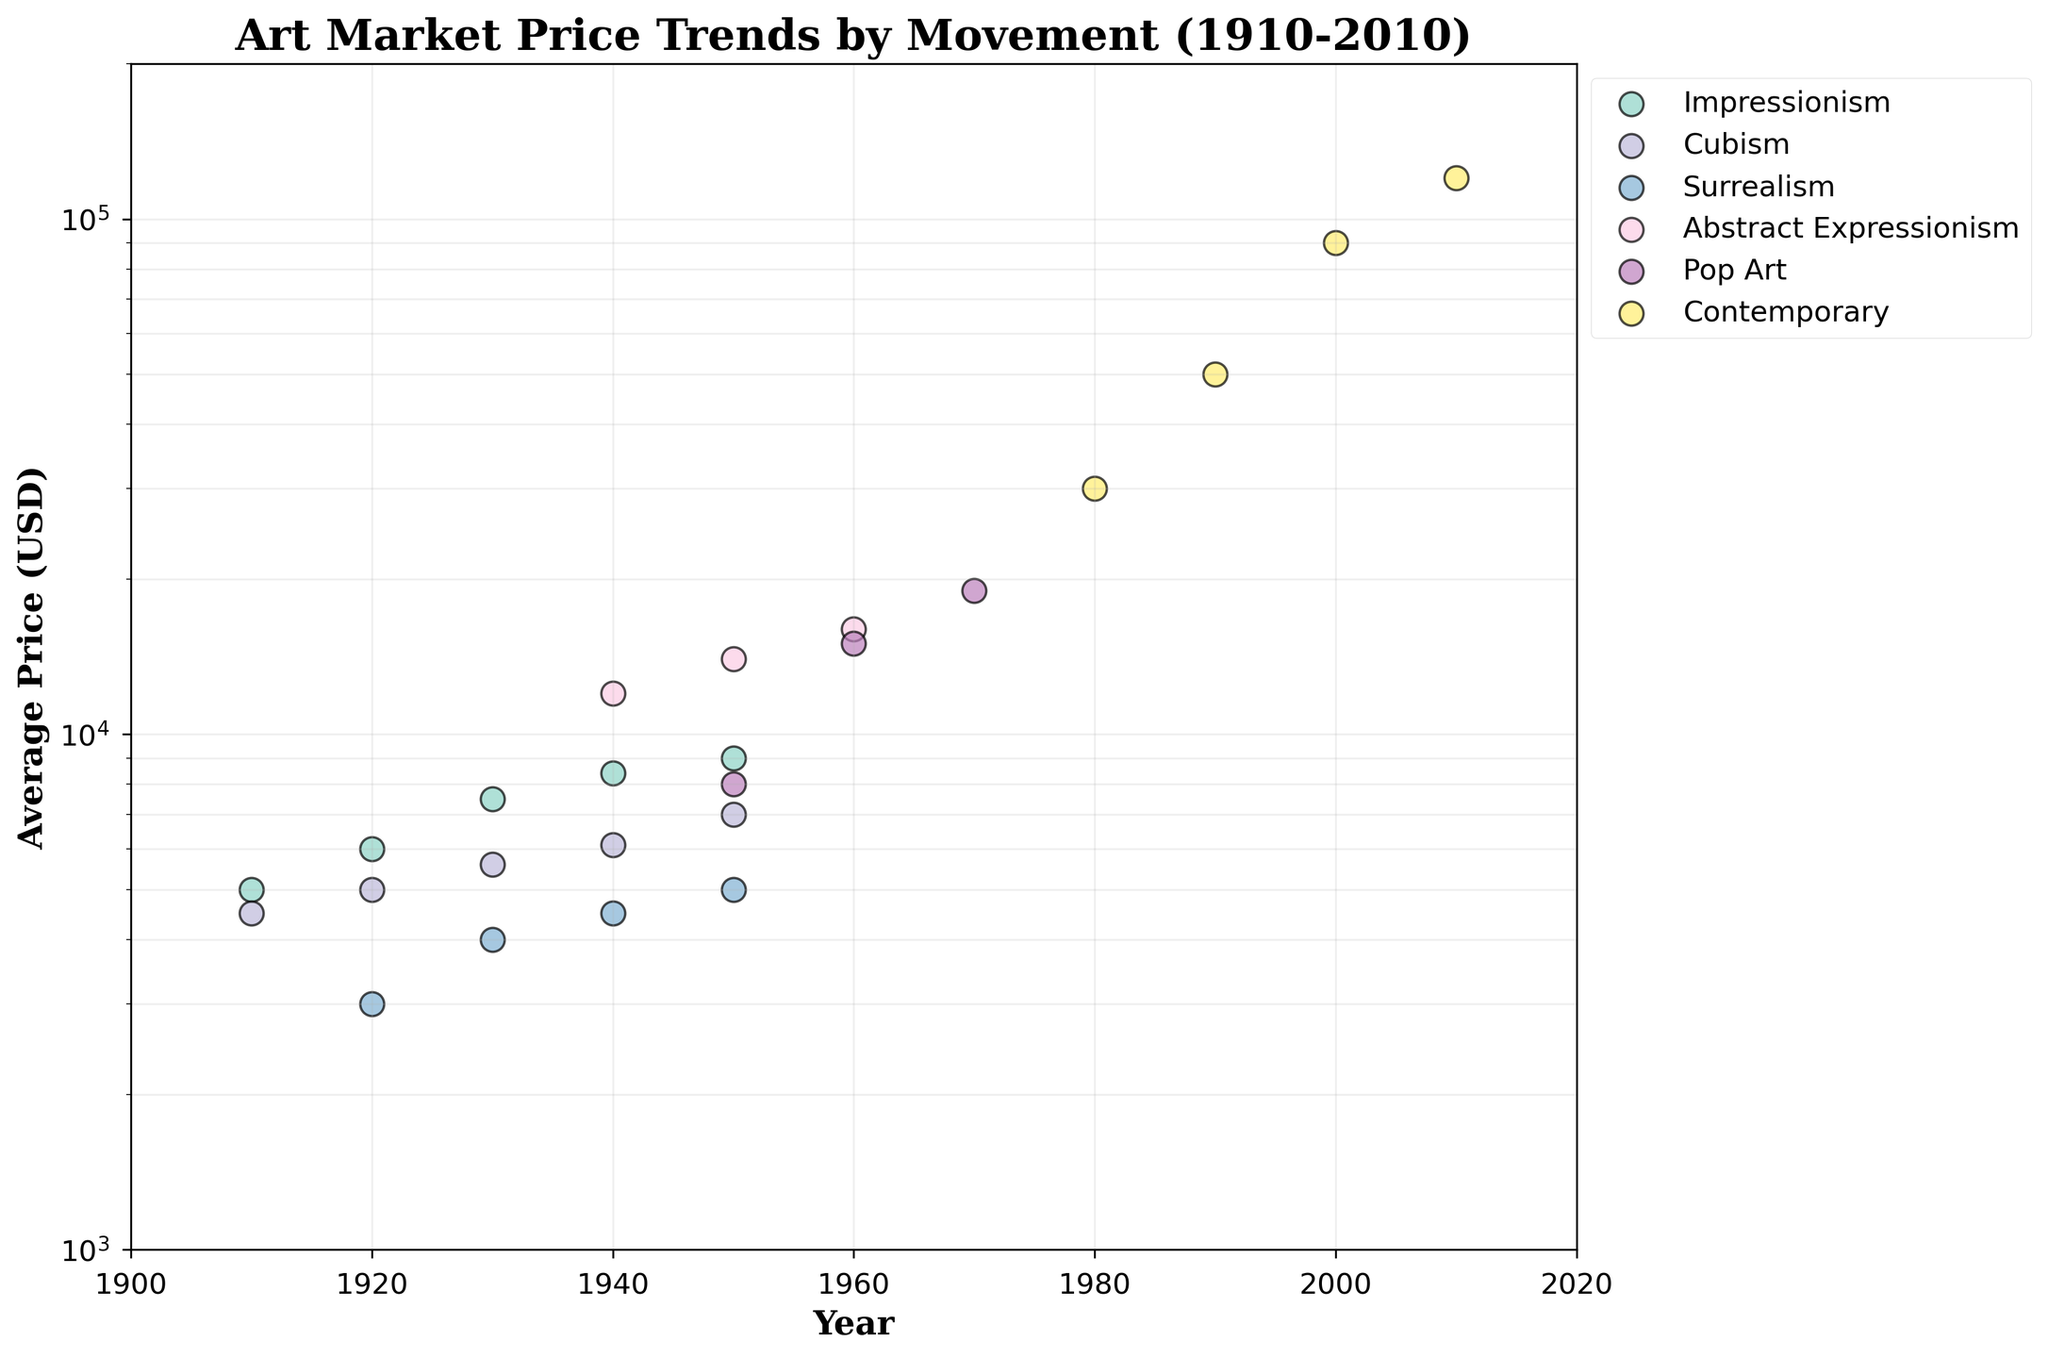What is the title of the chart? The title is found at the top of the chart, indicating the main subject being displayed.
Answer: Art Market Price Trends by Movement (1910-2010) Which art movement had the highest average price in 1950? Identify the data points corresponding to 1950 on the x-axis, then compare the average prices for different movements along the y-axis. The highest point will indicate the movement with the highest price.
Answer: Abstract Expressionism How did the average price of Impressionism change from 1910 to 1950? Calculate the difference between the average price of Impressionism in 1910 and 1950 by finding the data points for those years and subtracting the earlier price from the later one.
Answer: Increased by 4000 USD Which two art movements had data points around 1940, and which had the higher average price? Look for data points around the year 1940 and identify the movements associated with those points, then compare their average prices by referring to their positions along the y-axis.
Answer: Impressionism and Abstract Expressionism; Abstract Expressionism had the higher price What general trend can be observed in the average prices of Contemporary art from 1980 to 2010? Examine the data points for Contemporary art at 1980, 1990, 2000, and 2010, observing the changes in y-axis positions over time.
Answer: Prices are rising Which art movement shows the steepest increase in average price on the chart? Compare the slopes of the lines connecting data points for each movement. The movement with the most pronounced incline represents the steepest increase.
Answer: Contemporary What is the log-scaled y-axis range of the chart? Observe the minimum and maximum values indicated along the y-axis, which denotes the log-scaled average prices.
Answer: 1000 to 200000 USD How many movements are represented on the chart? Count the number of distinct legends or colored groups of data points in the chart.
Answer: Six Compare the average prices of Cubism and Surrealism in 1930. Which one was more expensive and by how much? Identify the data points for Cubism and Surrealism in 1930 and compare their positions on the y-axis to determine prices, then subtract the lower price from the higher one.
Answer: Cubism was more expensive by 1600 USD Which art movement does not have any data points before 1940? Identify the movements and their corresponding data points, then look for those without any points before the 1940 mark on the x-axis.
Answer: Abstract Expressionism, Pop Art, Contemporary 